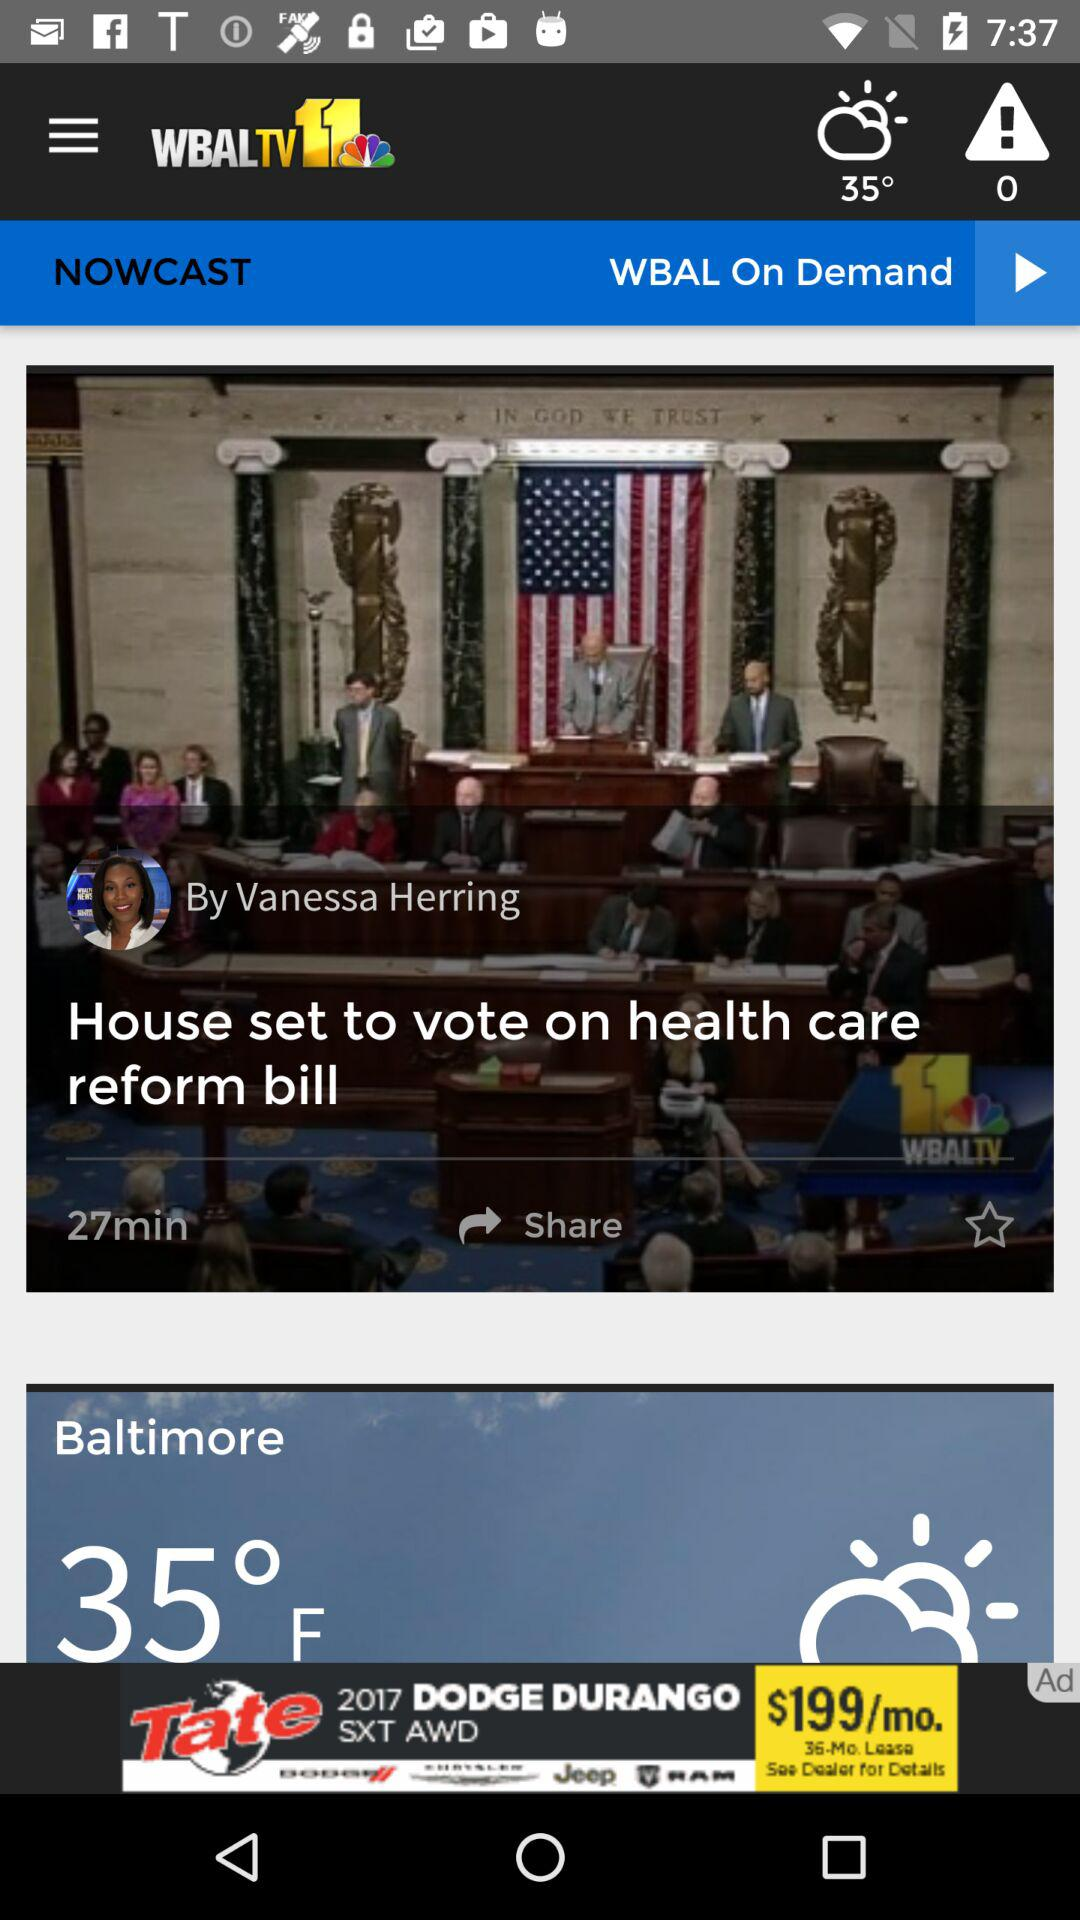How many degrees is the temperature in Baltimore?
Answer the question using a single word or phrase. 35° 